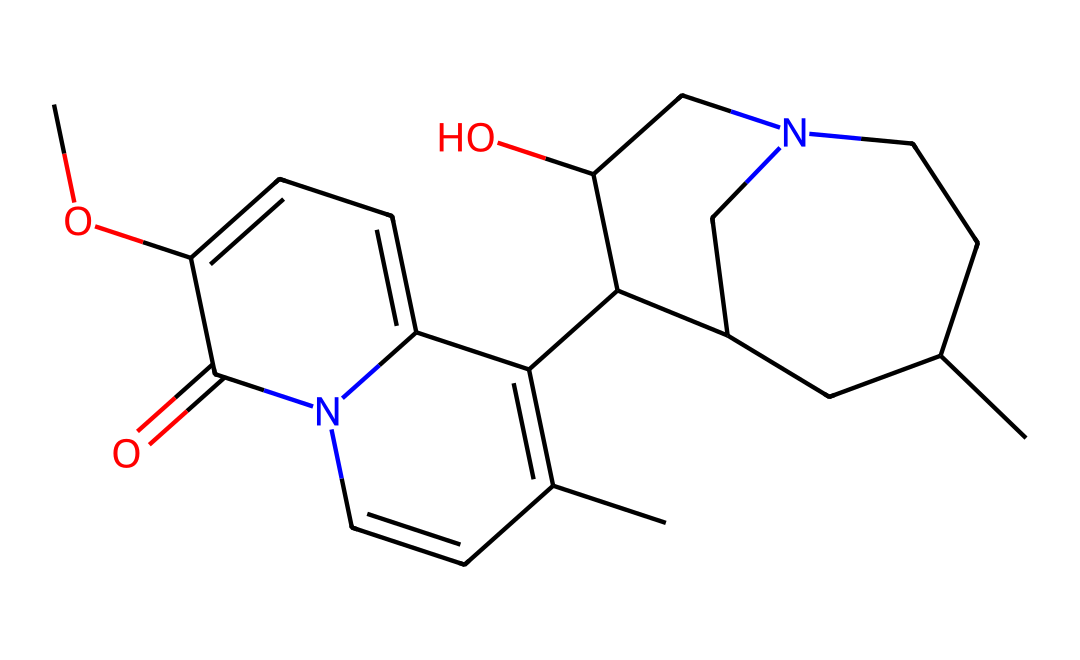What is the molecular formula of quinine? The SMILES representation can be translated to determine the number of carbon (C), hydrogen (H), nitrogen (N), and oxygen (O) atoms in the molecule. Counting the atoms from the SMILES results in C20, H24, N2, O2, forming the molecular formula C20H24N2O2.
Answer: C20H24N2O2 How many nitrogen atoms are present in the structure? By examining the SMILES string, we can spot the letters "N" representing nitrogen. In this case, there are two "N" in the structure indicating that there are two nitrogen atoms.
Answer: 2 What type of compound is quinine? Quinine is categorized as an alkaloid, which is a class of naturally occurring organic compounds that mostly contain basic nitrogen atoms. The presence of nitrogen in the structure aligns with the definition of alkaloids.
Answer: alkaloid Does this compound contain any rings in its structure? Looking at the SMILES, we can identify the presence of numbers indicating ring closures. The structure includes several numbers (1-4), which show that the compound has multiple cyclic components or rings.
Answer: yes What functional groups are present in quinine? Analyzing the SMILES representation, we see the presence of hydroxyl (-OH) and carbonyl (-C=O) functional groups. The -OH group is indicated by the "O" connected to a carbon, and the -C=O is shown as "C4=O" in the SMILES, confirming their presence in the compound.
Answer: hydroxyl, carbonyl Which feature in the chemical structure contributes to its medicinal properties? The presence of nitrogen atoms and their arrangement in the heterocyclic systems (the rings) generally increases the biological activity of alkaloids, including quinine, making it a crucial element contributing to its medicinal properties.
Answer: nitrogen atoms Is quinine a solid, liquid, or gas at room temperature? Quinine exists as a solid at room temperature. This can be inferred from its chemical structure and its known properties in pharmacology, where it is typically used in solid forms or as a powdered substance in tonic water.
Answer: solid 